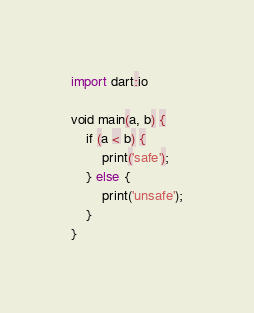<code> <loc_0><loc_0><loc_500><loc_500><_Dart_>import dart:io

void main(a, b) {
	if (a < b) {
    	print('safe');
    } else {
    	print('unsafe');
	}
}
</code> 